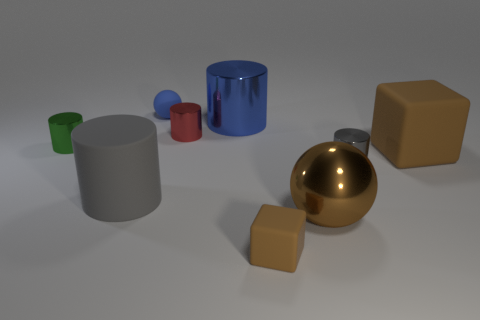Subtract all green cylinders. How many cylinders are left? 4 Subtract all small green metal cylinders. How many cylinders are left? 4 Subtract all brown cylinders. Subtract all brown balls. How many cylinders are left? 5 Add 1 small balls. How many objects exist? 10 Subtract all spheres. How many objects are left? 7 Add 4 small green things. How many small green things are left? 5 Add 8 large brown spheres. How many large brown spheres exist? 9 Subtract 0 yellow balls. How many objects are left? 9 Subtract all rubber cylinders. Subtract all blue shiny objects. How many objects are left? 7 